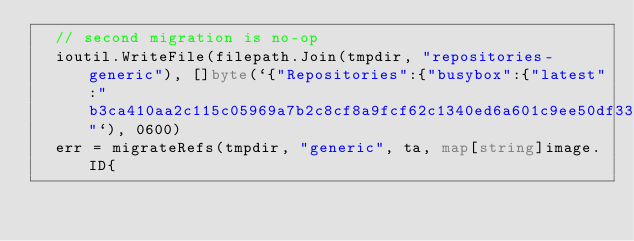<code> <loc_0><loc_0><loc_500><loc_500><_Go_>	// second migration is no-op
	ioutil.WriteFile(filepath.Join(tmpdir, "repositories-generic"), []byte(`{"Repositories":{"busybox":{"latest":"b3ca410aa2c115c05969a7b2c8cf8a9fcf62c1340ed6a601c9ee50df337ec108"`), 0600)
	err = migrateRefs(tmpdir, "generic", ta, map[string]image.ID{</code> 